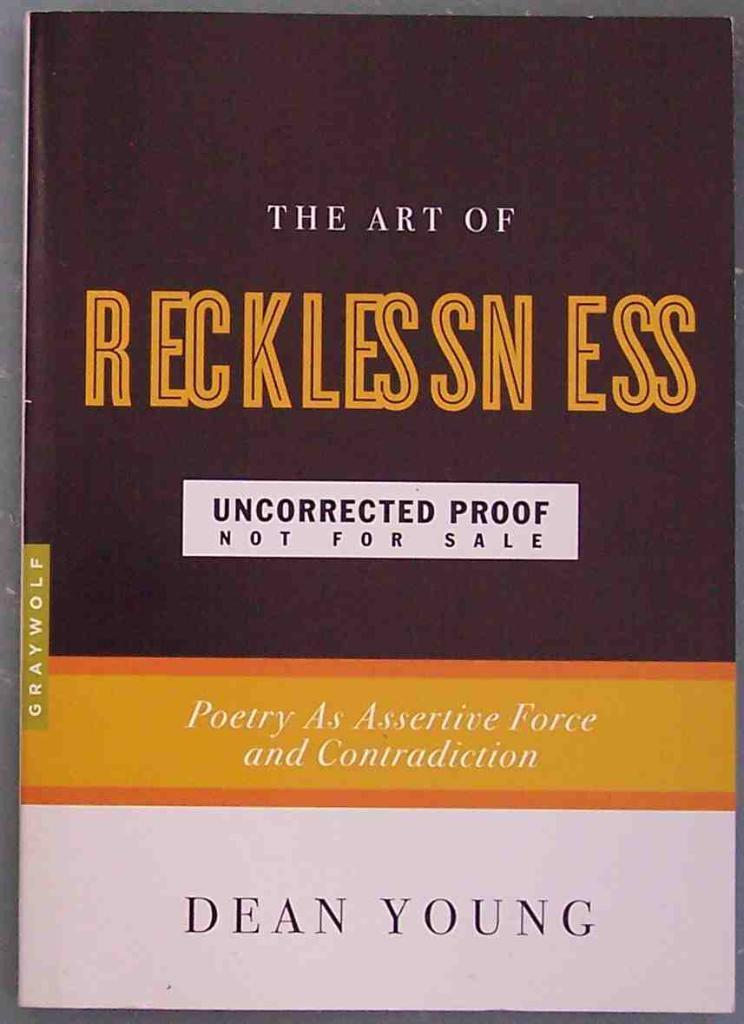<image>
Write a terse but informative summary of the picture. Book name The Art of Recklessnes by Dean Young 